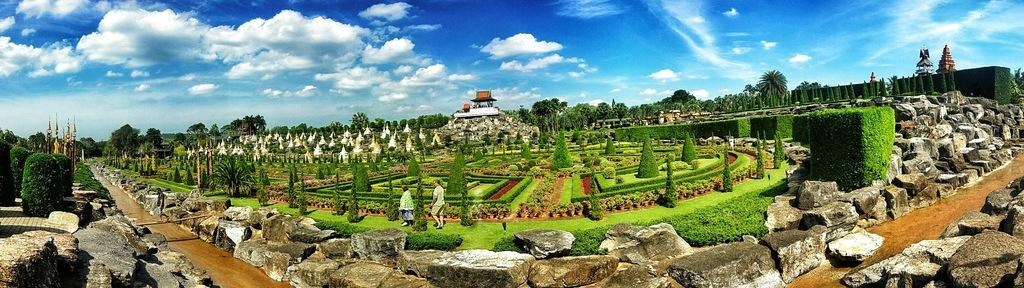Who or what can be seen in the image? There are people in the image. What type of natural environment is visible in the image? There is grass, plants, trees, and a path in the image. What can be seen in the background of the image? There are houses and the sky visible in the background of the image. What type of glass object is visible in the image? There is no glass object present in the image. Can you describe the observation made by the visitor in the image? There is no visitor present in the image, so no observation can be described. 